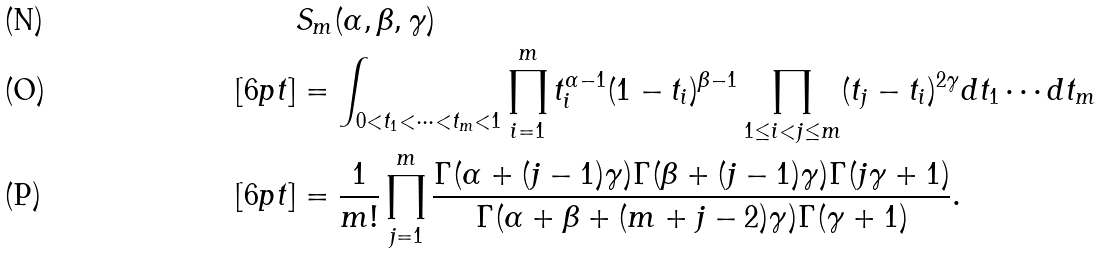Convert formula to latex. <formula><loc_0><loc_0><loc_500><loc_500>& S _ { m } ( \alpha , \beta , \gamma ) \\ [ 6 p t ] & = \int _ { 0 < t _ { 1 } < \cdots < t _ { m } < 1 } \prod _ { i = 1 } ^ { m } t _ { i } ^ { \alpha - 1 } ( 1 - t _ { i } ) ^ { \beta - 1 } \prod _ { 1 \leq i < j \leq m } ( t _ { j } - t _ { i } ) ^ { 2 \gamma } d t _ { 1 } \cdots d t _ { m } \\ [ 6 p t ] & = \frac { 1 } { m ! } \prod _ { j = 1 } ^ { m } \frac { \Gamma ( \alpha + ( j - 1 ) \gamma ) \Gamma ( \beta + ( j - 1 ) \gamma ) \Gamma ( j \gamma + 1 ) } { \Gamma ( \alpha + \beta + ( m + j - 2 ) \gamma ) \Gamma ( \gamma + 1 ) } .</formula> 